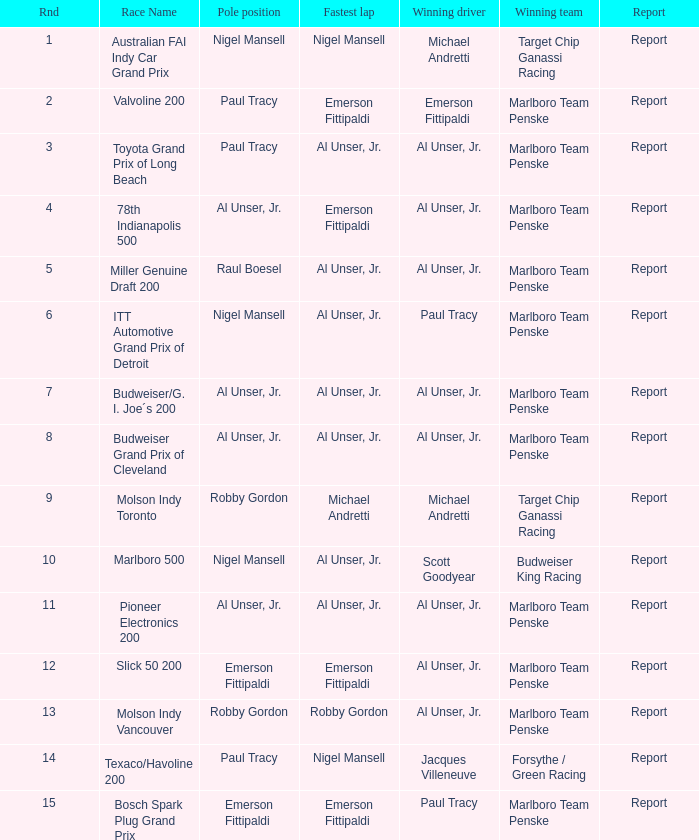In the itt automotive grand prix of detroit, which was won by paul tracy, who started at the pole position? Nigel Mansell. 